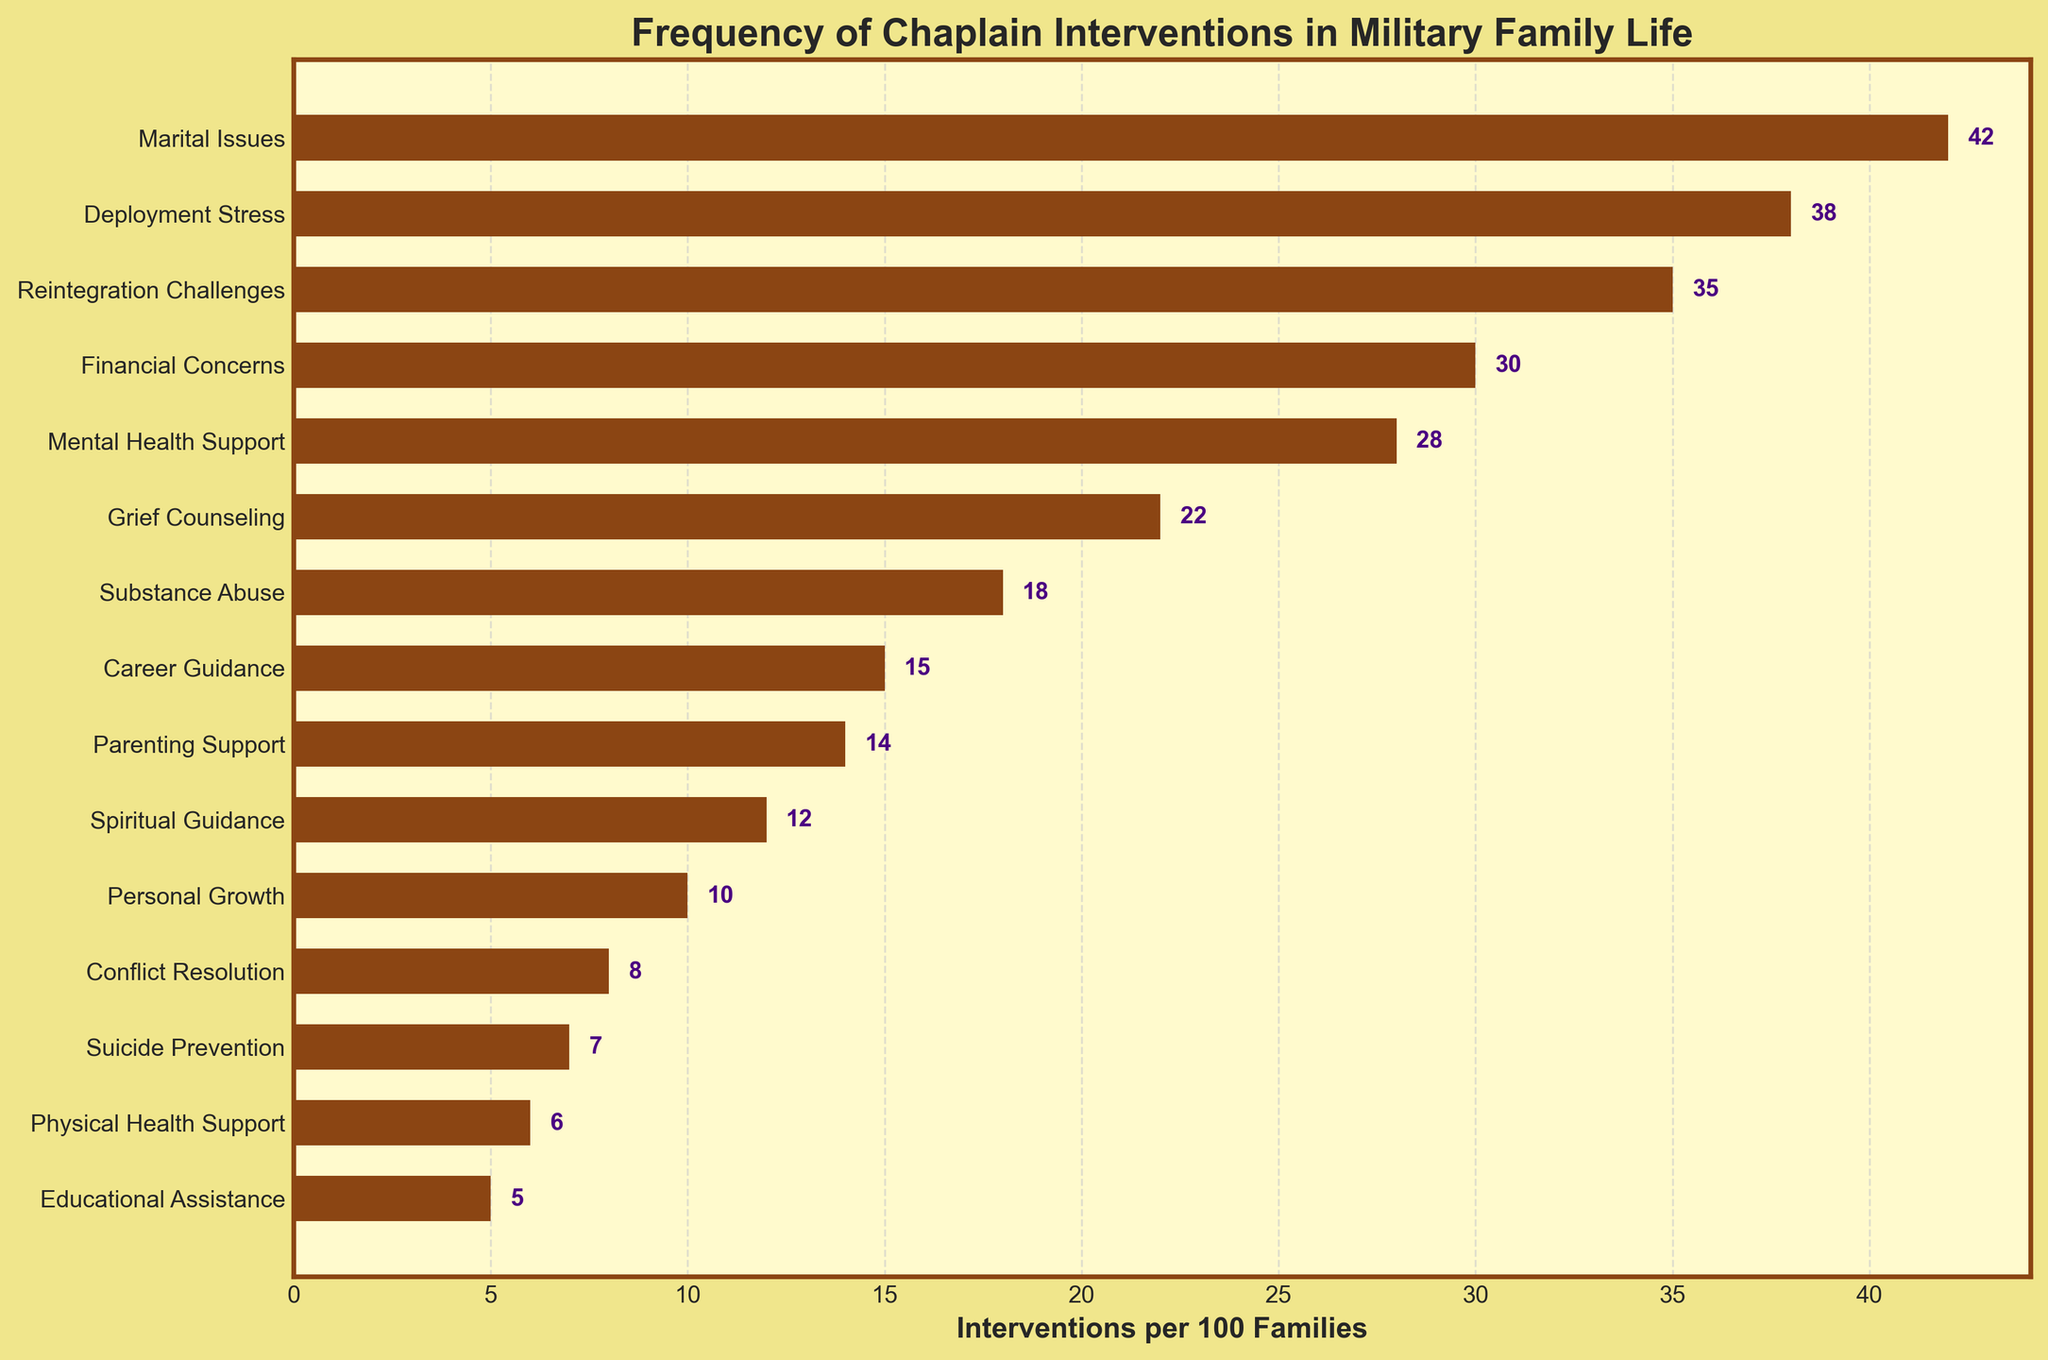Which area has the highest number of interventions per 100 families? According to the bar chart, the area with the longest bar represents the highest number of interventions. The longest bar corresponds to "Marital Issues" with 42 interventions.
Answer: Marital Issues Which area has the lowest number of interventions per 100 families? The area associated with the shortest bar represents the lowest number of interventions. "Educational Assistance" has the shortest bar with 5 interventions.
Answer: Educational Assistance How many more interventions are there for "Marital Issues" compared to "Mental Health Support"? Find the bars for "Marital Issues" and "Mental Health Support" in the chart. "Marital Issues" has 42 interventions, and "Mental Health Support" has 28. Subtract 28 from 42 to get the difference.
Answer: 14 What is the average number of interventions per 100 families across all areas? Sum all the interventions and divide by the number of areas. The sum is 42 + 38 + 35 + 30 + 28 + 22 + 18 + 15 + 14 + 12 + 10 + 8 + 7 + 6 + 5 = 290. The number of areas is 15. So, the average is 290/15 = 19.33.
Answer: 19.33 Is the number of interventions for "Deployment Stress" greater than or less than the interventions for "Financial Concerns"? Locate the bars for "Deployment Stress" (38 interventions) and "Financial Concerns" (30 interventions). Compare the two values.
Answer: Greater What is the median number of interventions per 100 families? Arrange all the intervention values in ascending order: 5, 6, 7, 8, 10, 12, 14, 15, 18, 22, 28, 30, 35, 38, 42. The median is the middle number in an ordered list. Here, the median is the 8th value, which is 15.
Answer: 15 Which areas have more than 20 interventions per 100 families? Identify areas with bars longer than the height corresponding to 20 interventions. The areas are "Marital Issues" (42), "Deployment Stress" (38), "Reintegration Challenges" (35), "Financial Concerns" (30), "Mental Health Support" (28), and "Grief Counseling" (22).
Answer: Marital Issues, Deployment Stress, Reintegration Challenges, Financial Concerns, Mental Health Support, Grief Counseling What is the total number of interventions for "Grief Counseling" and "Substance Abuse"? Sum the interventions for "Grief Counseling" (22) and "Substance Abuse" (18). 22 + 18 = 40.
Answer: 40 Between "Parenting Support" and "Spiritual Guidance," which area has fewer interventions? Compare the bars for "Parenting Support" (14 interventions) and "Spiritual Guidance" (12 interventions). "Spiritual Guidance" has fewer interventions.
Answer: Spiritual Guidance Are there more interventions for "Career Guidance" or "Conflict Resolution"? Compare the bars for "Career Guidance" (15 interventions) and "Conflict Resolution" (8 interventions). "Career Guidance" has more interventions.
Answer: Career Guidance 